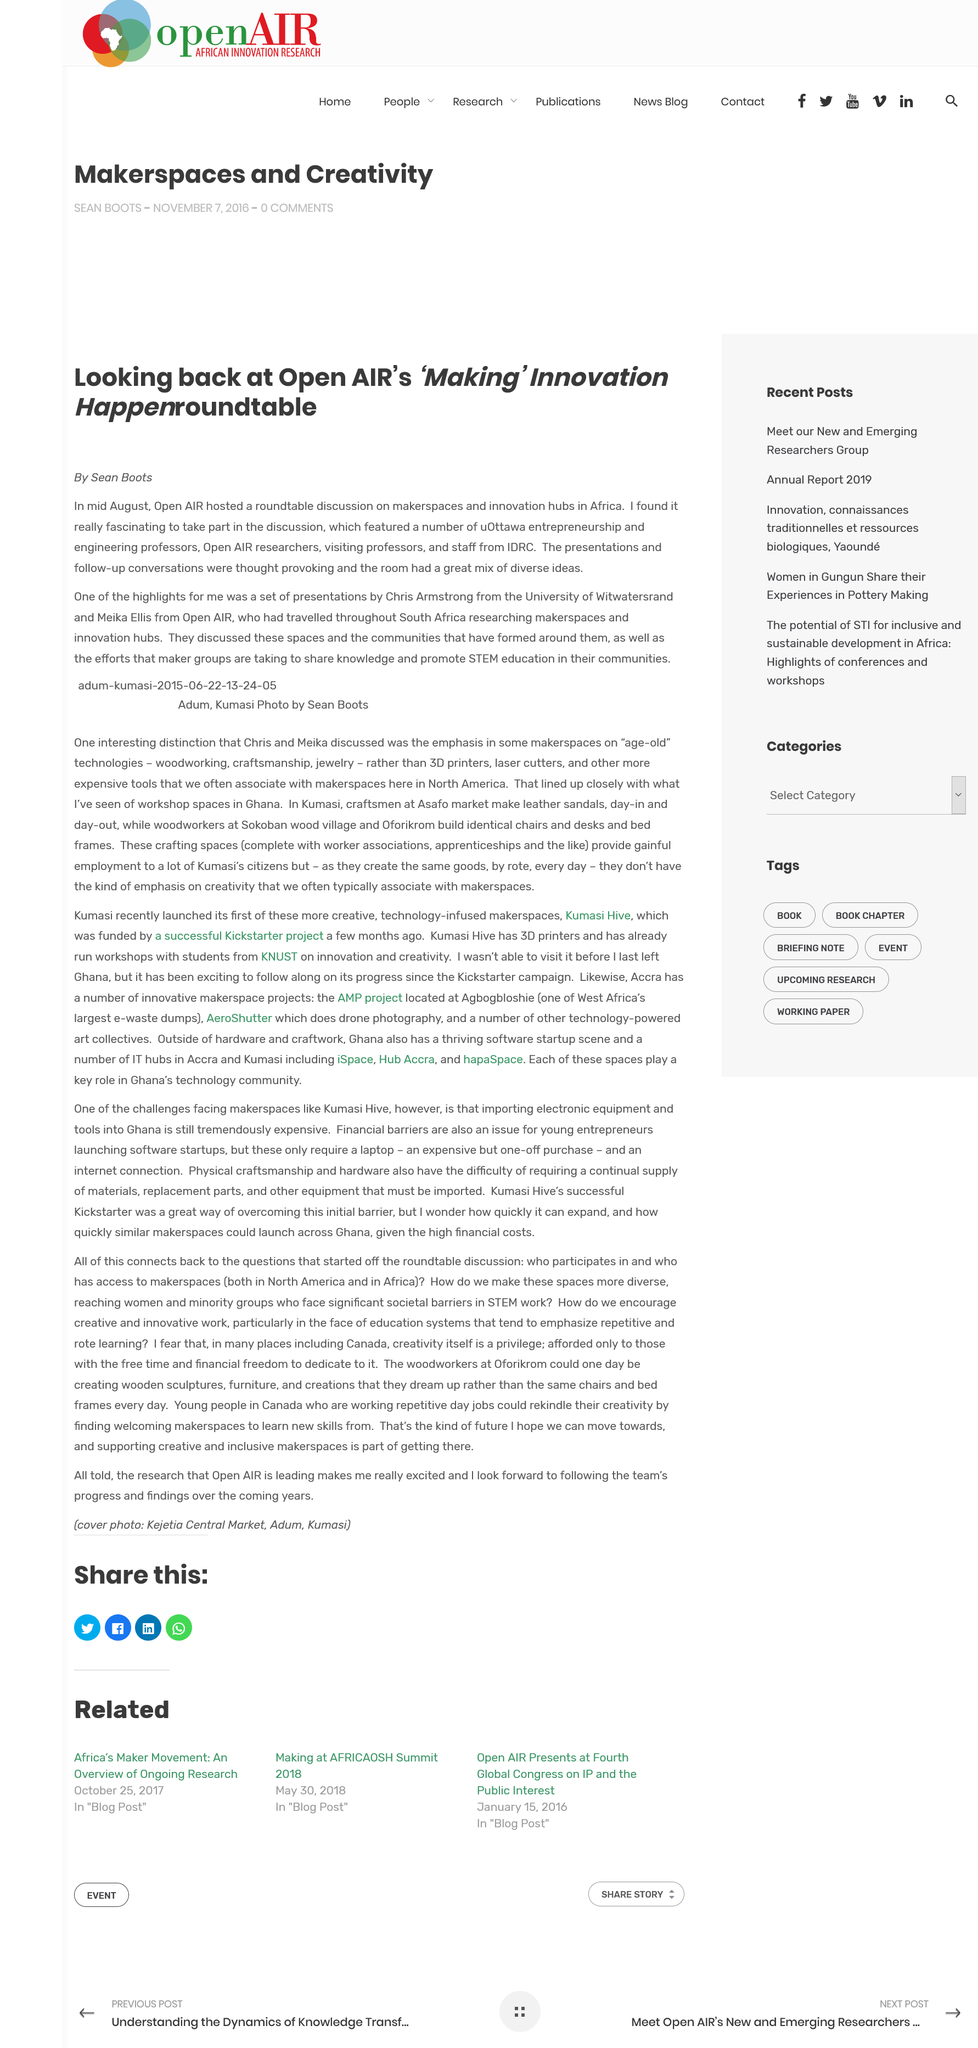Mention a couple of crucial points in this snapshot. The author of the article is Sean Boots. Open AIR hosted the "Making" Innovation Happen roundtable. On a journey throughout South Africa, Chris Armstrong and Meika Ellis explored and researched makerspaces and innovation hubs to gain a deeper understanding of these emerging trends in the field of education. 